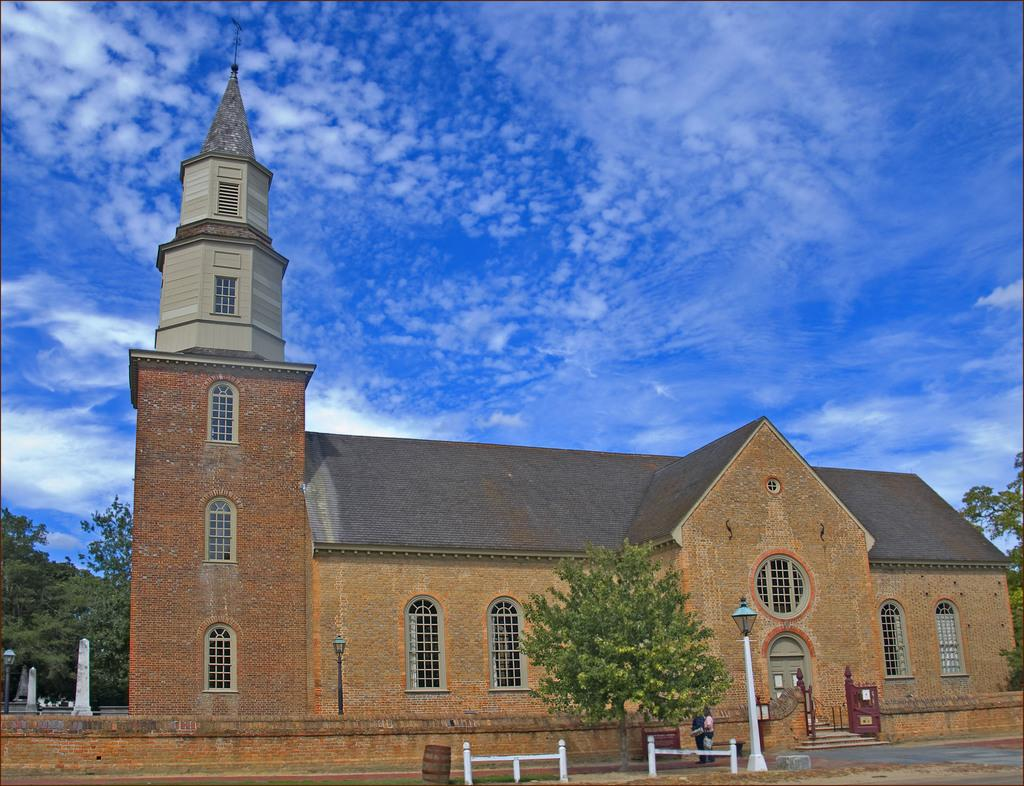What type of vegetation can be seen in the image? There are trees in the image. What is the color of the trees? The trees are green. What structure is present in the image besides the trees? There is a light pole and a building in the image. What is the color of the building? The building is brown. What can be seen in the background of the image? The sky is visible in the background of the image. What colors are present in the sky? The sky is blue and white. How many minutes does it take for the popcorn to pop in the image? There is no popcorn present in the image, so it is not possible to determine how long it would take for it to pop. 